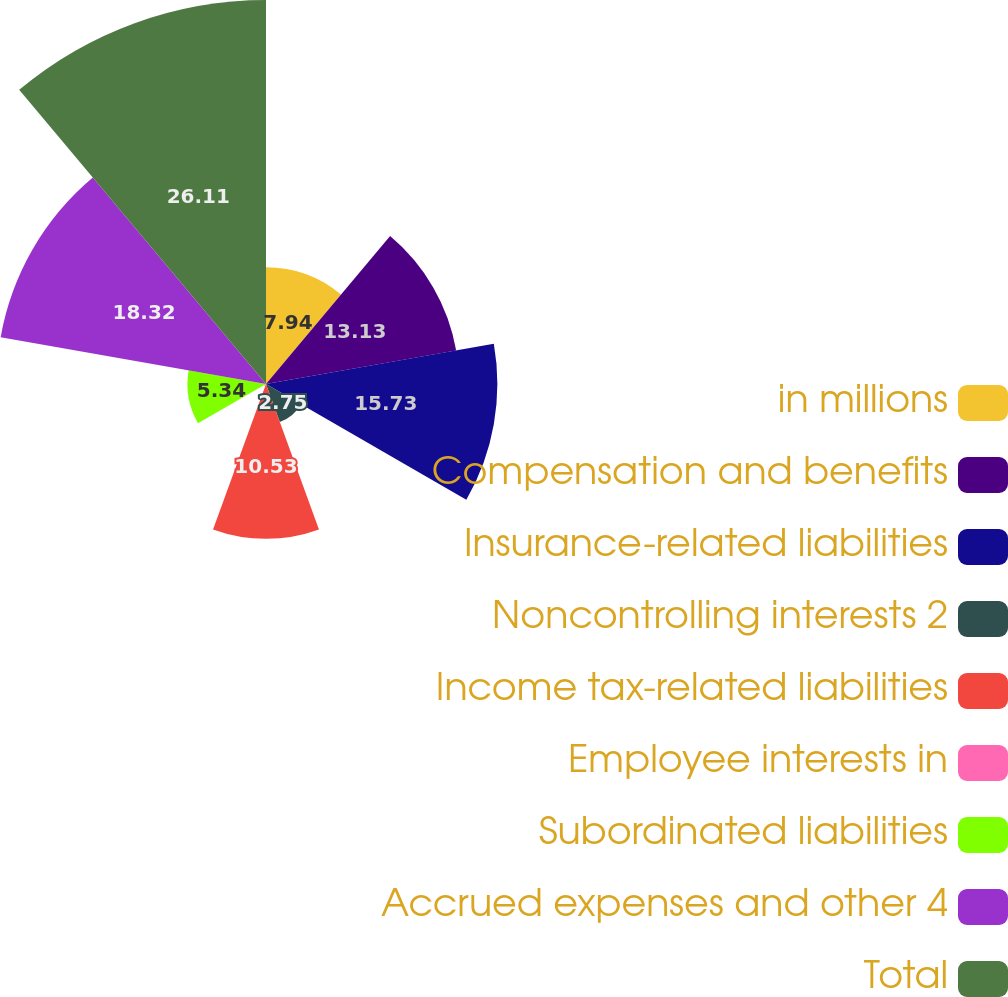Convert chart to OTSL. <chart><loc_0><loc_0><loc_500><loc_500><pie_chart><fcel>in millions<fcel>Compensation and benefits<fcel>Insurance-related liabilities<fcel>Noncontrolling interests 2<fcel>Income tax-related liabilities<fcel>Employee interests in<fcel>Subordinated liabilities<fcel>Accrued expenses and other 4<fcel>Total<nl><fcel>7.94%<fcel>13.13%<fcel>15.73%<fcel>2.75%<fcel>10.53%<fcel>0.15%<fcel>5.34%<fcel>18.32%<fcel>26.11%<nl></chart> 